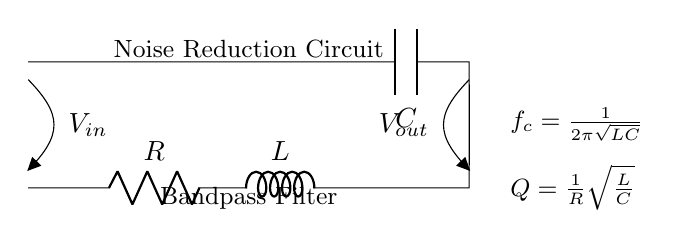What is the primary function of this circuit? The primary function of this circuit is to serve as a bandpass filter, which allows signals within a specific frequency range to pass while attenuating frequencies outside that range. This is evident from the configuration of a resistor, inductor, and capacitor working together to set the cutoff frequencies.
Answer: Bandpass filter What components are present in this circuit? The components in this circuit include a resistor, an inductor, and a capacitor. Each component is identified by its corresponding symbol in the diagram, where you can see the R, L, and C labels.
Answer: Resistor, inductor, capacitor What is the formula for the cutoff frequency? The formula for the cutoff frequency is displayed in the diagram as \( f_c = \frac{1}{2\pi\sqrt{LC}} \). This equation illustrates how the cutoff frequency depends on the values of the inductor and capacitor in the circuit.
Answer: 1 over 2 pi square root of LC What does the Q factor represent in this circuit? The Q factor, shown in the diagram as \( Q = \frac{1}{R}\sqrt{\frac{L}{C}} \), represents the quality factor of the circuit, indicating its selectivity and bandwidth. A higher Q factor means the filter is more selective, allowing only a narrow band of frequencies.
Answer: Quality factor How do the resistor, inductor, and capacitor interact in this circuit? The resistor, inductor, and capacitor interact in an RLC circuit by creating resonant behavior; at the resonant frequency, the impedance is minimized, allowing specific frequencies to pass while blocking others. The inductor and capacitor create a resonant circuit, and the resistor affects the bandwidth and the Q factor.
Answer: They create resonant behavior What kind of signals does this filter attenuate? This bandpass filter attenuates signals outside the designed frequency range, specifically low and high-frequency signals that do not meet the bandpass criteria, which is determined by the values of R, L, and C.
Answer: Low and high-frequency signals What is the role of each component in maintaining noise reduction? The resistor limits the current, the inductor stores energy in a magnetic field, and the capacitor stores energy in an electric field. Together, they create a frequency response that enhances desired signals while reducing noise, which is essential for clear audio in recording equipment.
Answer: To enhance desired signals and reduce noise 